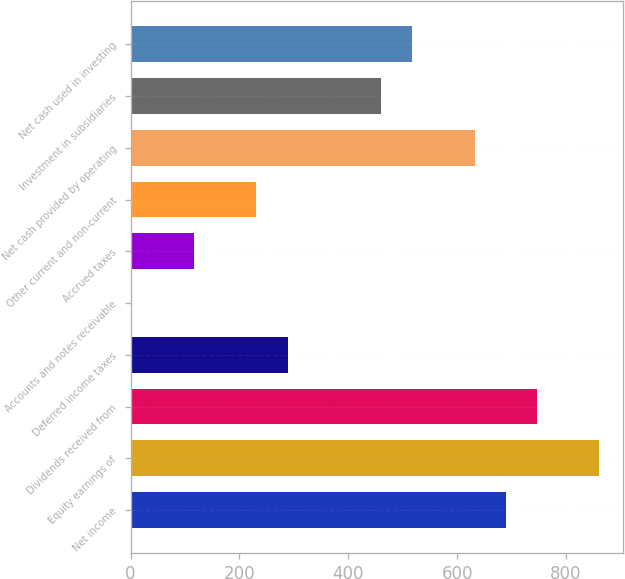Convert chart. <chart><loc_0><loc_0><loc_500><loc_500><bar_chart><fcel>Net income<fcel>Equity earnings of<fcel>Dividends received from<fcel>Deferred income taxes<fcel>Accounts and notes receivable<fcel>Accrued taxes<fcel>Other current and non-current<fcel>Net cash provided by operating<fcel>Investment in subsidiaries<fcel>Net cash used in investing<nl><fcel>689.6<fcel>861.5<fcel>746.9<fcel>288.5<fcel>2<fcel>116.6<fcel>231.2<fcel>632.3<fcel>460.4<fcel>517.7<nl></chart> 